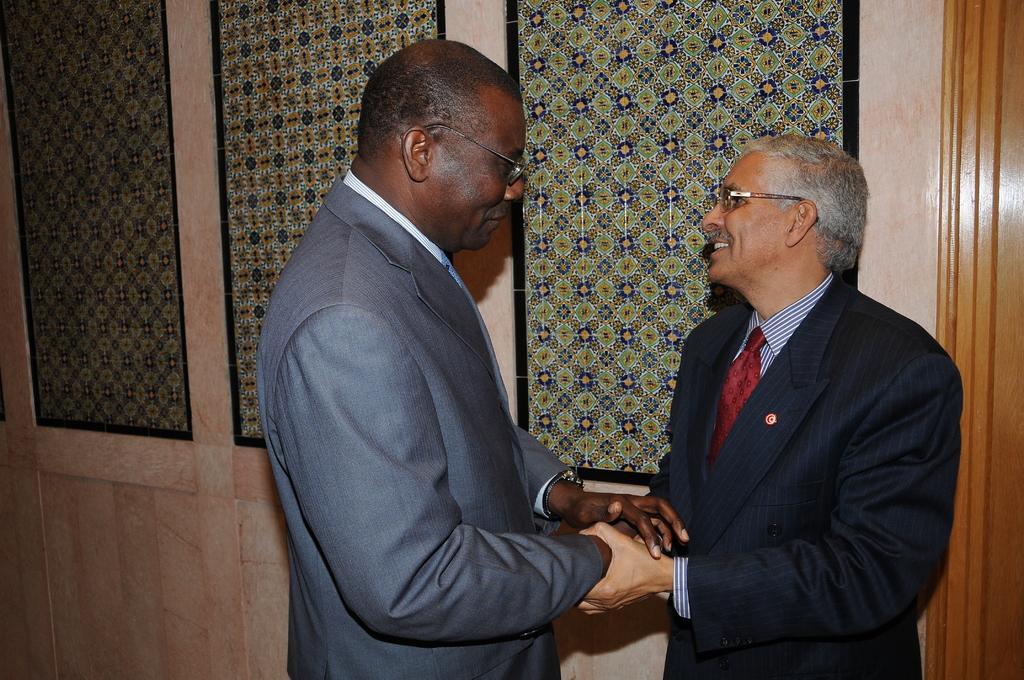Could you give a brief overview of what you see in this image? In the image in the center, we can see two persons are standing and they are holding hands. And we can see they are smiling, which we can see on their faces. In the background there is a wall and frames. 